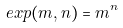Convert formula to latex. <formula><loc_0><loc_0><loc_500><loc_500>e x p ( m , n ) = m ^ { n }</formula> 